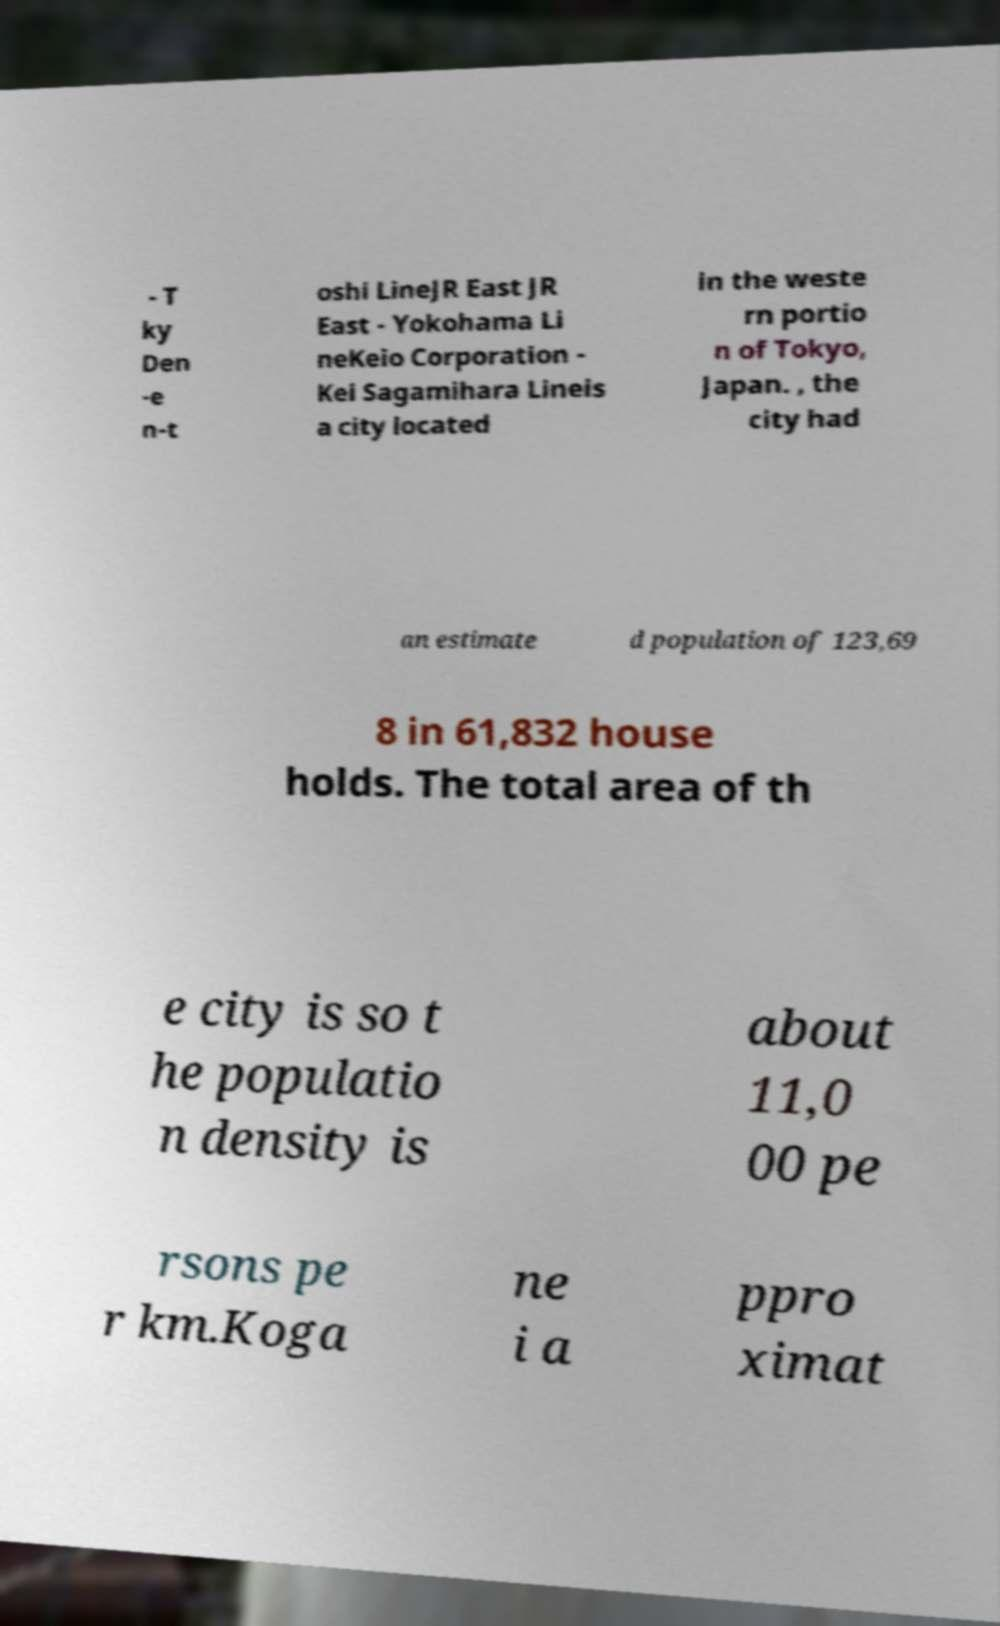What messages or text are displayed in this image? I need them in a readable, typed format. - T ky Den -e n-t oshi LineJR East JR East - Yokohama Li neKeio Corporation - Kei Sagamihara Lineis a city located in the weste rn portio n of Tokyo, Japan. , the city had an estimate d population of 123,69 8 in 61,832 house holds. The total area of th e city is so t he populatio n density is about 11,0 00 pe rsons pe r km.Koga ne i a ppro ximat 